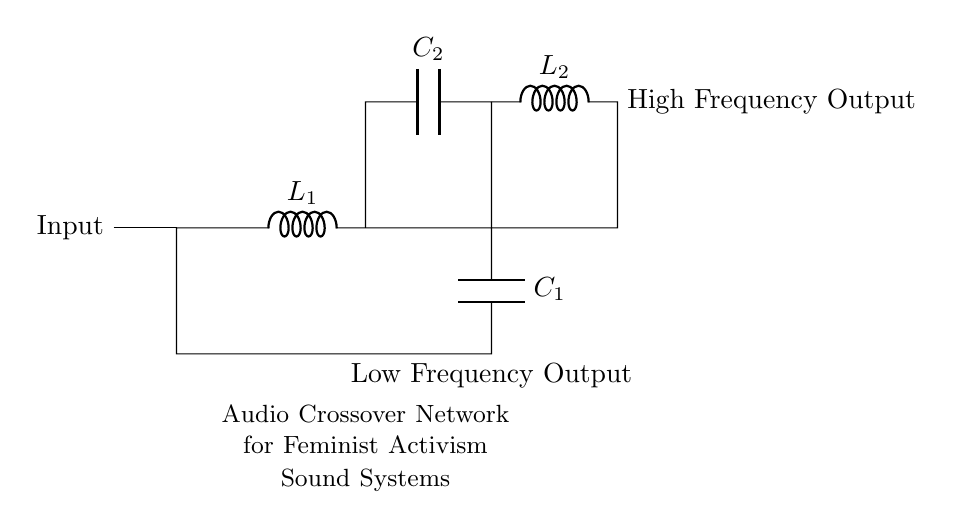What is the type of the input signal? The circuit shows that the input is a short, indicating a signal input point where audio is received.
Answer: Audio input What components are used for high-frequency filtering? The circuit includes an inductor and a capacitor in series, which form a filter for high-frequency signals as seen on the right side.
Answer: Inductor and capacitor Which output is for low frequencies? The output connected to the capacitor and inductor at the bottom of the circuit indicates that it is specifically designed for low frequencies.
Answer: Low Frequency Output What is the function of the inductor labeled L1? In inductive circuits, L1 is utilized for filtering, specifically to block high frequencies while allowing low frequencies to pass through, as described by its connection in the circuit.
Answer: To block high frequencies What is the total number of capacitors in the circuit? By counting the components labeled as capacitors, two are present on the diagram, both denoted as C1 and C2.
Answer: Two Why are capacitors used in a crossover network? Capacitors enable the passage of high-frequency signals while obstructing low-frequency signals, serving as the essential filtering component in audio applications where different frequencies need to be separated.
Answer: To separate frequencies Which component is responsible for low-frequency output? The capacitor connected at the bottom of the diagram is directly responsible for allowing low frequencies to be output, as indicated by its position and labeling.
Answer: Capacitor C1 